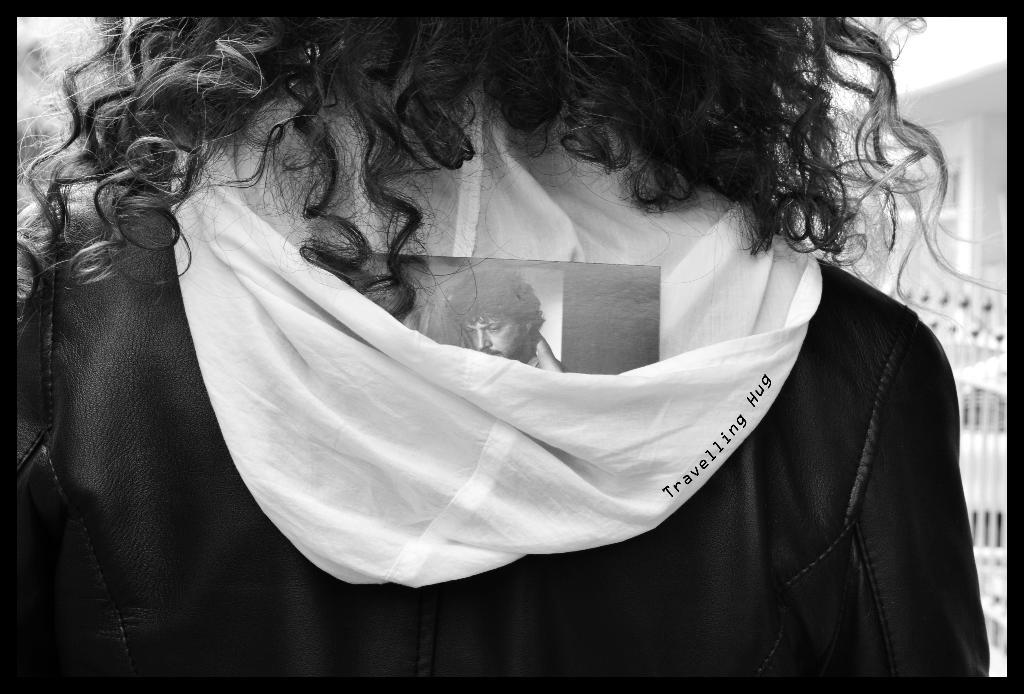What is present in the image? There is a person in the image. What is the person wearing? The person is wearing a jacket. What type of silver plough is the person using in the image? There is no plough or silver object present in the image; it only features a person wearing a jacket. 